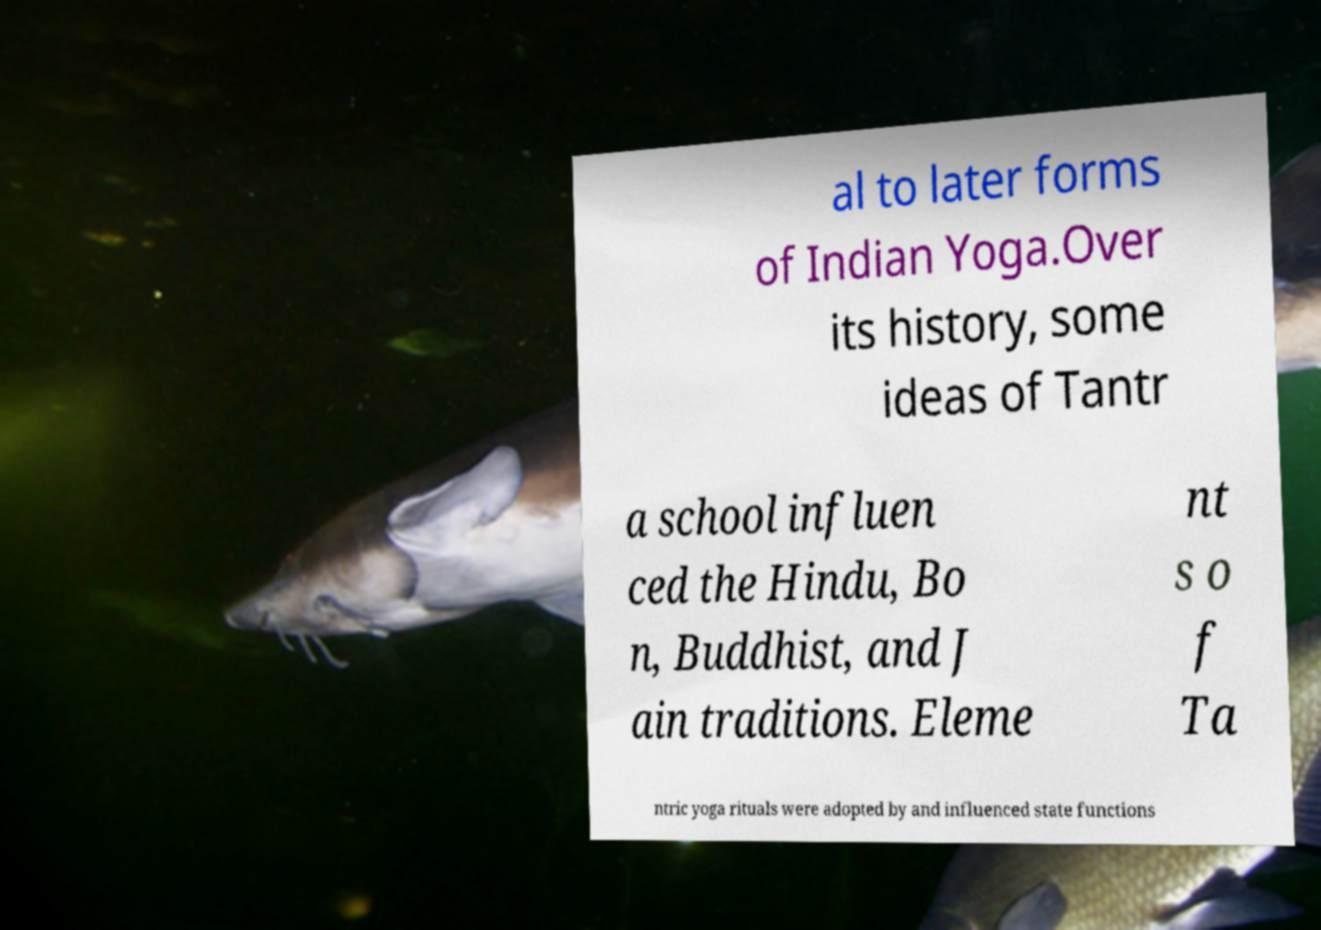Can you accurately transcribe the text from the provided image for me? al to later forms of Indian Yoga.Over its history, some ideas of Tantr a school influen ced the Hindu, Bo n, Buddhist, and J ain traditions. Eleme nt s o f Ta ntric yoga rituals were adopted by and influenced state functions 